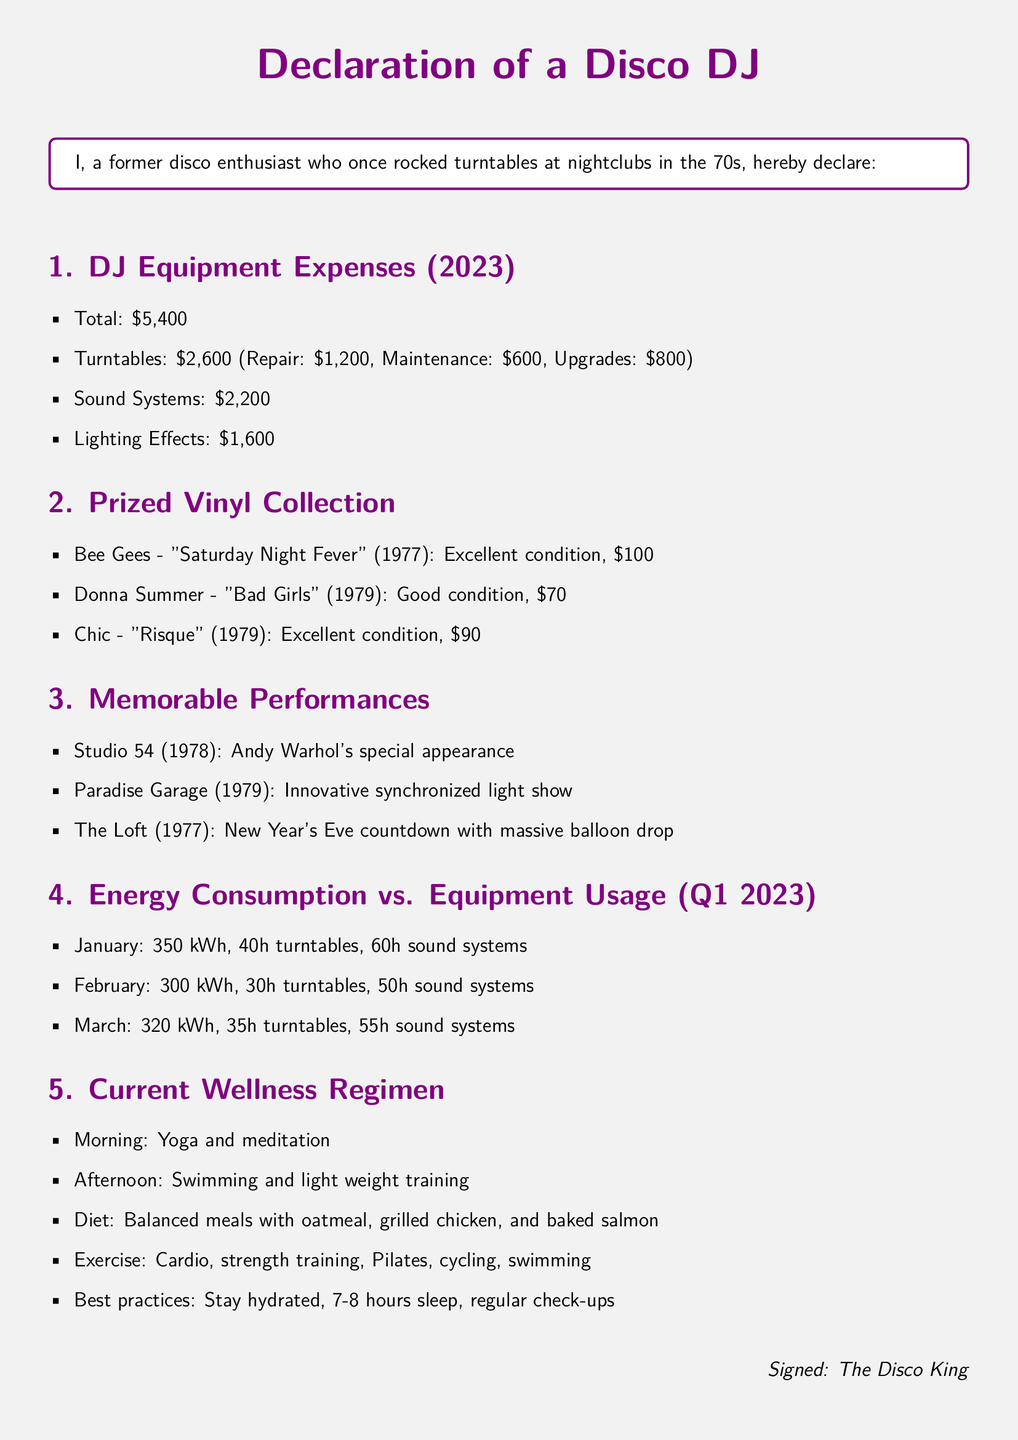What is the total amount spent on DJ equipment repairs? The total amount spent is listed clearly in the document, adding all expenses under DJ Equipment Expenses.
Answer: $5,400 How much was spent on turntables? The turntable expenses include specific amounts for repair, maintenance, and upgrades, which total to $2,600.
Answer: $2,600 What is the condition of the "Bad Girls" vinyl? The document specifies the condition of each vinyl record collected, noting that "Bad Girls" is in good condition.
Answer: Good condition Which nightclub featured Andy Warhol's special appearance? The performances section highlights notable events, specifying which venue hosted Andy Warhol.
Answer: Studio 54 What was the energy consumption in February 2023? The document provides the kWh values for each month, listing February's energy consumption.
Answer: 300 kWh How many hours were the sound systems used in January? The document lists usage hours for each type of equipment, providing the specific number for sound systems in January.
Answer: 60h What type of diet is included in the wellness regimen? The wellness regimen outlines dietary practices, emphasizing balanced meals which includes specific foods.
Answer: Balanced meals How many notable performances are listed in the document? The document presents a clear count of performances mentioned in the overview section.
Answer: Three performances When did the New Year's Eve countdown take place? The performances section includes dates associated with memorable events, identifying the year of the New Year's Eve countdown.
Answer: 1977 